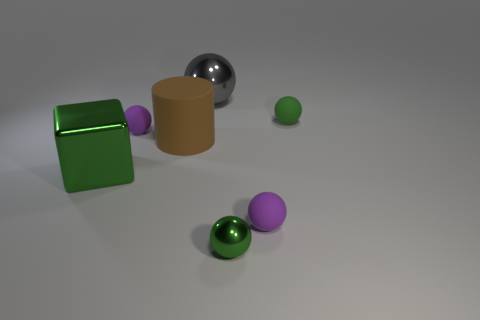Subtract all green balls. How many were subtracted if there are1green balls left? 1 Subtract all purple rubber spheres. How many spheres are left? 3 Subtract all green spheres. How many spheres are left? 3 Subtract 3 spheres. How many spheres are left? 2 Add 1 small green shiny cylinders. How many objects exist? 8 Subtract all balls. How many objects are left? 2 Subtract all gray cylinders. How many purple balls are left? 2 Add 5 large cyan matte objects. How many large cyan matte objects exist? 5 Subtract 1 green blocks. How many objects are left? 6 Subtract all brown spheres. Subtract all gray cubes. How many spheres are left? 5 